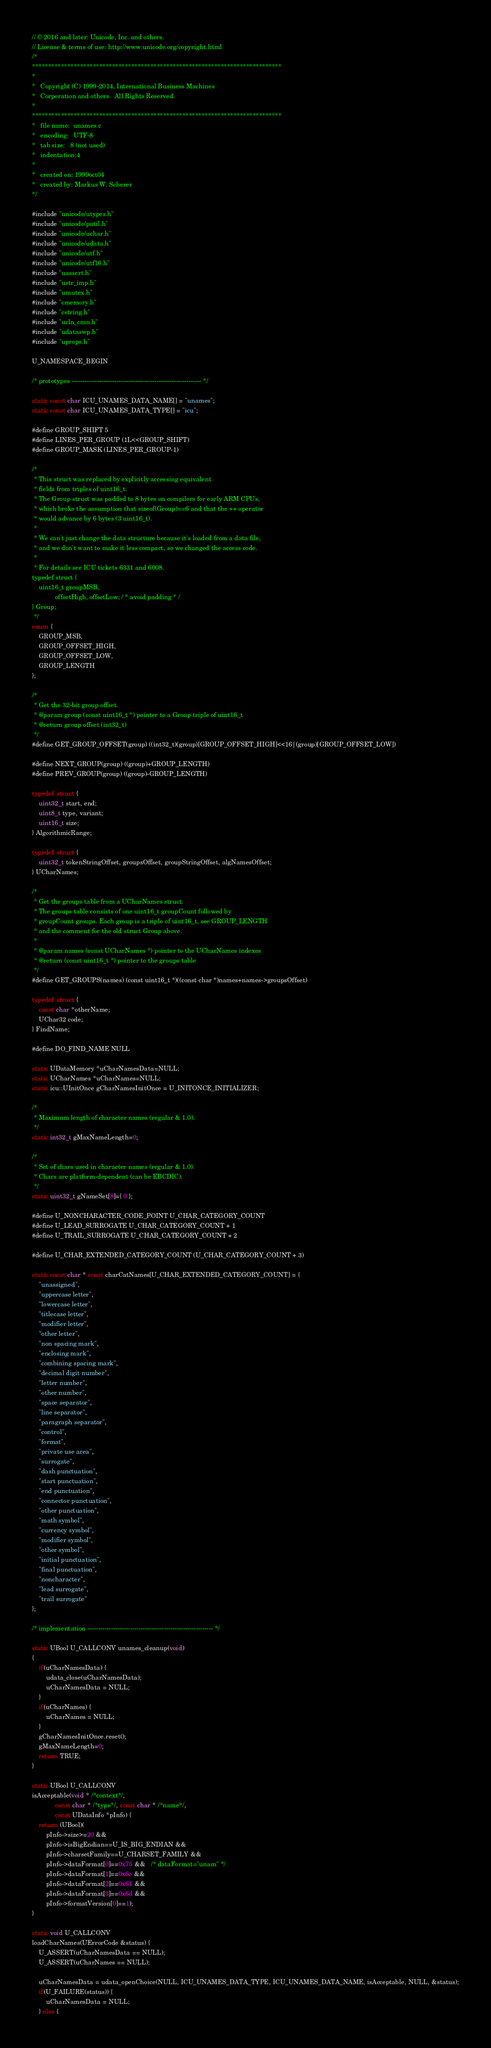<code> <loc_0><loc_0><loc_500><loc_500><_C++_>// © 2016 and later: Unicode, Inc. and others.
// License & terms of use: http://www.unicode.org/copyright.html
/*
******************************************************************************
*
*   Copyright (C) 1999-2014, International Business Machines
*   Corporation and others.  All Rights Reserved.
*
******************************************************************************
*   file name:  unames.c
*   encoding:   UTF-8
*   tab size:   8 (not used)
*   indentation:4
*
*   created on: 1999oct04
*   created by: Markus W. Scherer
*/

#include "unicode/utypes.h"
#include "unicode/putil.h"
#include "unicode/uchar.h"
#include "unicode/udata.h"
#include "unicode/utf.h"
#include "unicode/utf16.h"
#include "uassert.h"
#include "ustr_imp.h"
#include "umutex.h"
#include "cmemory.h"
#include "cstring.h"
#include "ucln_cmn.h"
#include "udataswp.h"
#include "uprops.h"

U_NAMESPACE_BEGIN

/* prototypes ------------------------------------------------------------- */

static const char ICU_UNAMES_DATA_NAME[] = "unames";
static const char ICU_UNAMES_DATA_TYPE[] = "icu";

#define GROUP_SHIFT 5
#define LINES_PER_GROUP (1L<<GROUP_SHIFT)
#define GROUP_MASK (LINES_PER_GROUP-1)

/*
 * This struct was replaced by explicitly accessing equivalent
 * fields from triples of uint16_t.
 * The Group struct was padded to 8 bytes on compilers for early ARM CPUs,
 * which broke the assumption that sizeof(Group)==6 and that the ++ operator
 * would advance by 6 bytes (3 uint16_t).
 *
 * We can't just change the data structure because it's loaded from a data file,
 * and we don't want to make it less compact, so we changed the access code.
 *
 * For details see ICU tickets 6331 and 6008.
typedef struct {
    uint16_t groupMSB,
             offsetHigh, offsetLow; / * avoid padding * /
} Group;
 */
enum {
    GROUP_MSB,
    GROUP_OFFSET_HIGH,
    GROUP_OFFSET_LOW,
    GROUP_LENGTH
};

/*
 * Get the 32-bit group offset.
 * @param group (const uint16_t *) pointer to a Group triple of uint16_t
 * @return group offset (int32_t)
 */
#define GET_GROUP_OFFSET(group) ((int32_t)(group)[GROUP_OFFSET_HIGH]<<16|(group)[GROUP_OFFSET_LOW])

#define NEXT_GROUP(group) ((group)+GROUP_LENGTH)
#define PREV_GROUP(group) ((group)-GROUP_LENGTH)

typedef struct {
    uint32_t start, end;
    uint8_t type, variant;
    uint16_t size;
} AlgorithmicRange;

typedef struct {
    uint32_t tokenStringOffset, groupsOffset, groupStringOffset, algNamesOffset;
} UCharNames;

/*
 * Get the groups table from a UCharNames struct.
 * The groups table consists of one uint16_t groupCount followed by
 * groupCount groups. Each group is a triple of uint16_t, see GROUP_LENGTH
 * and the comment for the old struct Group above.
 *
 * @param names (const UCharNames *) pointer to the UCharNames indexes
 * @return (const uint16_t *) pointer to the groups table
 */
#define GET_GROUPS(names) (const uint16_t *)((const char *)names+names->groupsOffset)

typedef struct {
    const char *otherName;
    UChar32 code;
} FindName;

#define DO_FIND_NAME NULL

static UDataMemory *uCharNamesData=NULL;
static UCharNames *uCharNames=NULL;
static icu::UInitOnce gCharNamesInitOnce = U_INITONCE_INITIALIZER;

/*
 * Maximum length of character names (regular & 1.0).
 */
static int32_t gMaxNameLength=0;

/*
 * Set of chars used in character names (regular & 1.0).
 * Chars are platform-dependent (can be EBCDIC).
 */
static uint32_t gNameSet[8]={ 0 };

#define U_NONCHARACTER_CODE_POINT U_CHAR_CATEGORY_COUNT
#define U_LEAD_SURROGATE U_CHAR_CATEGORY_COUNT + 1
#define U_TRAIL_SURROGATE U_CHAR_CATEGORY_COUNT + 2

#define U_CHAR_EXTENDED_CATEGORY_COUNT (U_CHAR_CATEGORY_COUNT + 3)

static const char * const charCatNames[U_CHAR_EXTENDED_CATEGORY_COUNT] = {
    "unassigned",
    "uppercase letter",
    "lowercase letter",
    "titlecase letter",
    "modifier letter",
    "other letter",
    "non spacing mark",
    "enclosing mark",
    "combining spacing mark",
    "decimal digit number",
    "letter number",
    "other number",
    "space separator",
    "line separator",
    "paragraph separator",
    "control",
    "format",
    "private use area",
    "surrogate",
    "dash punctuation",
    "start punctuation",
    "end punctuation",
    "connector punctuation",
    "other punctuation",
    "math symbol",
    "currency symbol",
    "modifier symbol",
    "other symbol",
    "initial punctuation",
    "final punctuation",
    "noncharacter",
    "lead surrogate",
    "trail surrogate"
};

/* implementation ----------------------------------------------------------- */

static UBool U_CALLCONV unames_cleanup(void)
{
    if(uCharNamesData) {
        udata_close(uCharNamesData);
        uCharNamesData = NULL;
    }
    if(uCharNames) {
        uCharNames = NULL;
    }
    gCharNamesInitOnce.reset();
    gMaxNameLength=0;
    return TRUE;
}

static UBool U_CALLCONV
isAcceptable(void * /*context*/,
             const char * /*type*/, const char * /*name*/,
             const UDataInfo *pInfo) {
    return (UBool)(
        pInfo->size>=20 &&
        pInfo->isBigEndian==U_IS_BIG_ENDIAN &&
        pInfo->charsetFamily==U_CHARSET_FAMILY &&
        pInfo->dataFormat[0]==0x75 &&   /* dataFormat="unam" */
        pInfo->dataFormat[1]==0x6e &&
        pInfo->dataFormat[2]==0x61 &&
        pInfo->dataFormat[3]==0x6d &&
        pInfo->formatVersion[0]==1);
}

static void U_CALLCONV
loadCharNames(UErrorCode &status) {
    U_ASSERT(uCharNamesData == NULL);
    U_ASSERT(uCharNames == NULL);

    uCharNamesData = udata_openChoice(NULL, ICU_UNAMES_DATA_TYPE, ICU_UNAMES_DATA_NAME, isAcceptable, NULL, &status);
    if(U_FAILURE(status)) {
        uCharNamesData = NULL;
    } else {</code> 